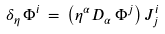<formula> <loc_0><loc_0><loc_500><loc_500>\delta _ { \eta } \, \Phi ^ { i } \, = \, \left ( \eta ^ { \alpha } D _ { \alpha } \, \Phi ^ { j } \right ) J ^ { i } _ { j }</formula> 